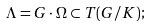Convert formula to latex. <formula><loc_0><loc_0><loc_500><loc_500>\Lambda = G \cdot \Omega \subset T ( G / K ) ;</formula> 